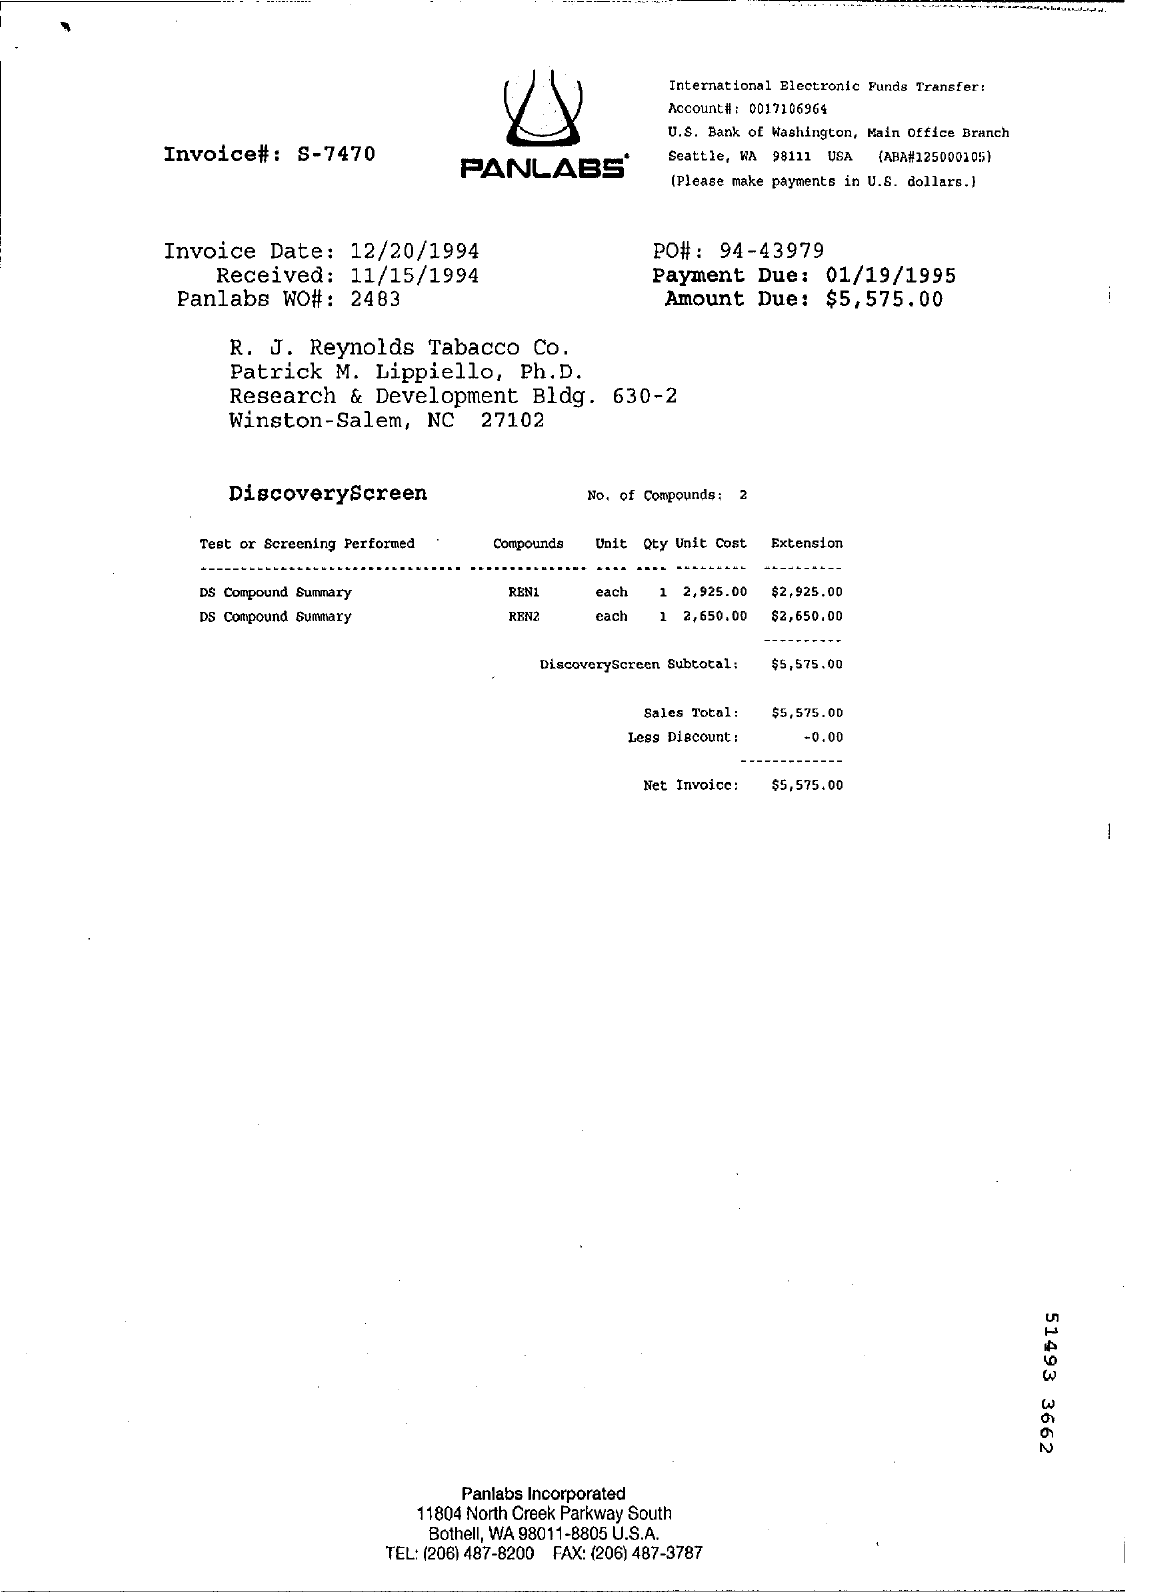What is the name of lab written on top
Offer a very short reply. Panlabs. What is the Invoice Date  given
Ensure brevity in your answer.  12/20/1994. What is the payment Due Date
Your response must be concise. 01/19/1995. What Amount Due is given
Provide a succinct answer. $5,575.00. 